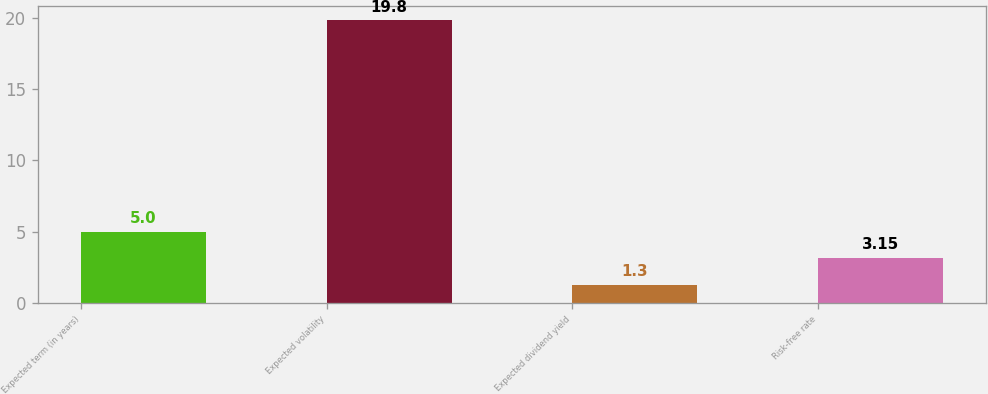<chart> <loc_0><loc_0><loc_500><loc_500><bar_chart><fcel>Expected term (in years)<fcel>Expected volatility<fcel>Expected dividend yield<fcel>Risk-free rate<nl><fcel>5<fcel>19.8<fcel>1.3<fcel>3.15<nl></chart> 